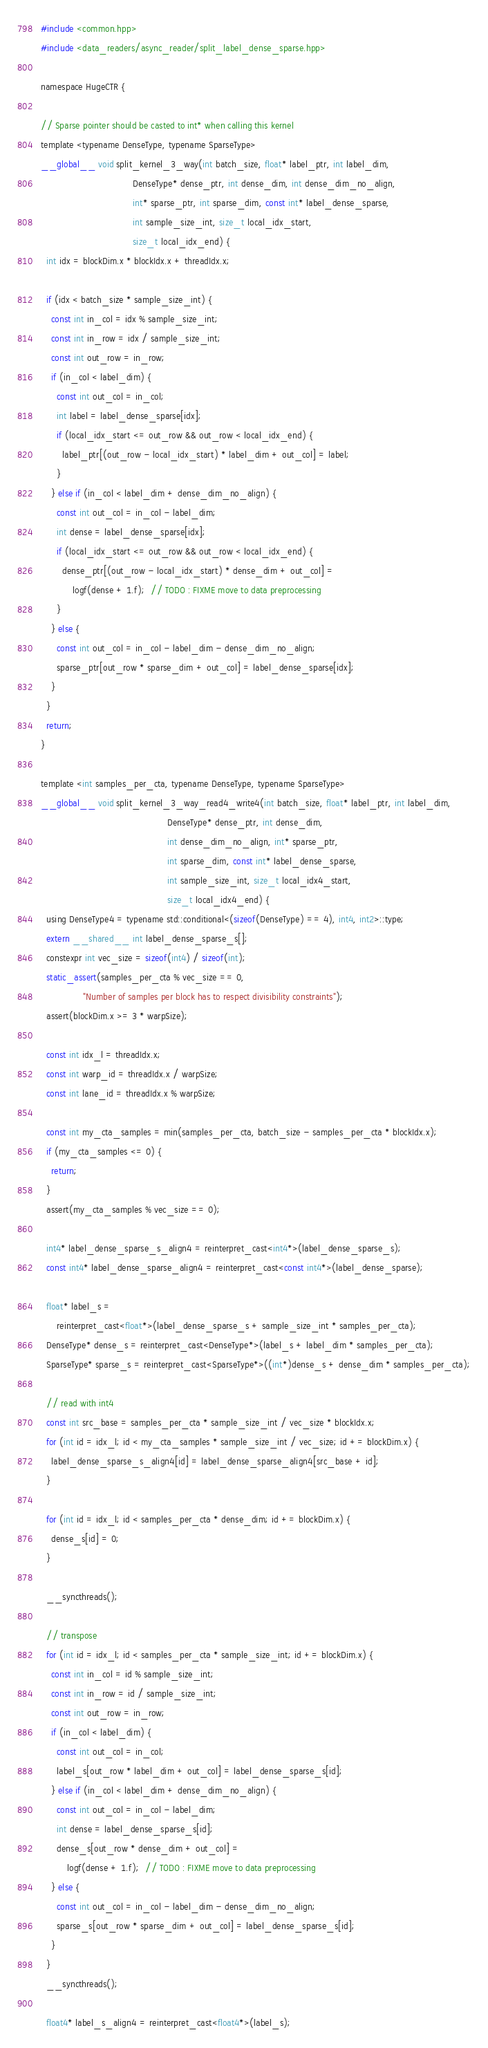<code> <loc_0><loc_0><loc_500><loc_500><_Cuda_>#include <common.hpp>
#include <data_readers/async_reader/split_label_dense_sparse.hpp>

namespace HugeCTR {

// Sparse pointer should be casted to int* when calling this kernel
template <typename DenseType, typename SparseType>
__global__ void split_kernel_3_way(int batch_size, float* label_ptr, int label_dim,
                                   DenseType* dense_ptr, int dense_dim, int dense_dim_no_align,
                                   int* sparse_ptr, int sparse_dim, const int* label_dense_sparse,
                                   int sample_size_int, size_t local_idx_start,
                                   size_t local_idx_end) {
  int idx = blockDim.x * blockIdx.x + threadIdx.x;

  if (idx < batch_size * sample_size_int) {
    const int in_col = idx % sample_size_int;
    const int in_row = idx / sample_size_int;
    const int out_row = in_row;
    if (in_col < label_dim) {
      const int out_col = in_col;
      int label = label_dense_sparse[idx];
      if (local_idx_start <= out_row && out_row < local_idx_end) {
        label_ptr[(out_row - local_idx_start) * label_dim + out_col] = label;
      }
    } else if (in_col < label_dim + dense_dim_no_align) {
      const int out_col = in_col - label_dim;
      int dense = label_dense_sparse[idx];
      if (local_idx_start <= out_row && out_row < local_idx_end) {
        dense_ptr[(out_row - local_idx_start) * dense_dim + out_col] =
            logf(dense + 1.f);  // TODO : FIXME move to data preprocessing
      }
    } else {
      const int out_col = in_col - label_dim - dense_dim_no_align;
      sparse_ptr[out_row * sparse_dim + out_col] = label_dense_sparse[idx];
    }
  }
  return;
}

template <int samples_per_cta, typename DenseType, typename SparseType>
__global__ void split_kernel_3_way_read4_write4(int batch_size, float* label_ptr, int label_dim,
                                                DenseType* dense_ptr, int dense_dim,
                                                int dense_dim_no_align, int* sparse_ptr,
                                                int sparse_dim, const int* label_dense_sparse,
                                                int sample_size_int, size_t local_idx4_start,
                                                size_t local_idx4_end) {
  using DenseType4 = typename std::conditional<(sizeof(DenseType) == 4), int4, int2>::type;
  extern __shared__ int label_dense_sparse_s[];
  constexpr int vec_size = sizeof(int4) / sizeof(int);
  static_assert(samples_per_cta % vec_size == 0,
                "Number of samples per block has to respect divisibility constraints");
  assert(blockDim.x >= 3 * warpSize);

  const int idx_l = threadIdx.x;
  const int warp_id = threadIdx.x / warpSize;
  const int lane_id = threadIdx.x % warpSize;

  const int my_cta_samples = min(samples_per_cta, batch_size - samples_per_cta * blockIdx.x);
  if (my_cta_samples <= 0) {
    return;
  }
  assert(my_cta_samples % vec_size == 0);

  int4* label_dense_sparse_s_align4 = reinterpret_cast<int4*>(label_dense_sparse_s);
  const int4* label_dense_sparse_align4 = reinterpret_cast<const int4*>(label_dense_sparse);

  float* label_s =
      reinterpret_cast<float*>(label_dense_sparse_s + sample_size_int * samples_per_cta);
  DenseType* dense_s = reinterpret_cast<DenseType*>(label_s + label_dim * samples_per_cta);
  SparseType* sparse_s = reinterpret_cast<SparseType*>((int*)dense_s + dense_dim * samples_per_cta);

  // read with int4
  const int src_base = samples_per_cta * sample_size_int / vec_size * blockIdx.x;
  for (int id = idx_l; id < my_cta_samples * sample_size_int / vec_size; id += blockDim.x) {
    label_dense_sparse_s_align4[id] = label_dense_sparse_align4[src_base + id];
  }

  for (int id = idx_l; id < samples_per_cta * dense_dim; id += blockDim.x) {
    dense_s[id] = 0;
  }

  __syncthreads();

  // transpose
  for (int id = idx_l; id < samples_per_cta * sample_size_int; id += blockDim.x) {
    const int in_col = id % sample_size_int;
    const int in_row = id / sample_size_int;
    const int out_row = in_row;
    if (in_col < label_dim) {
      const int out_col = in_col;
      label_s[out_row * label_dim + out_col] = label_dense_sparse_s[id];
    } else if (in_col < label_dim + dense_dim_no_align) {
      const int out_col = in_col - label_dim;
      int dense = label_dense_sparse_s[id];
      dense_s[out_row * dense_dim + out_col] =
          logf(dense + 1.f);  // TODO : FIXME move to data preprocessing
    } else {
      const int out_col = in_col - label_dim - dense_dim_no_align;
      sparse_s[out_row * sparse_dim + out_col] = label_dense_sparse_s[id];
    }
  }
  __syncthreads();

  float4* label_s_align4 = reinterpret_cast<float4*>(label_s);</code> 